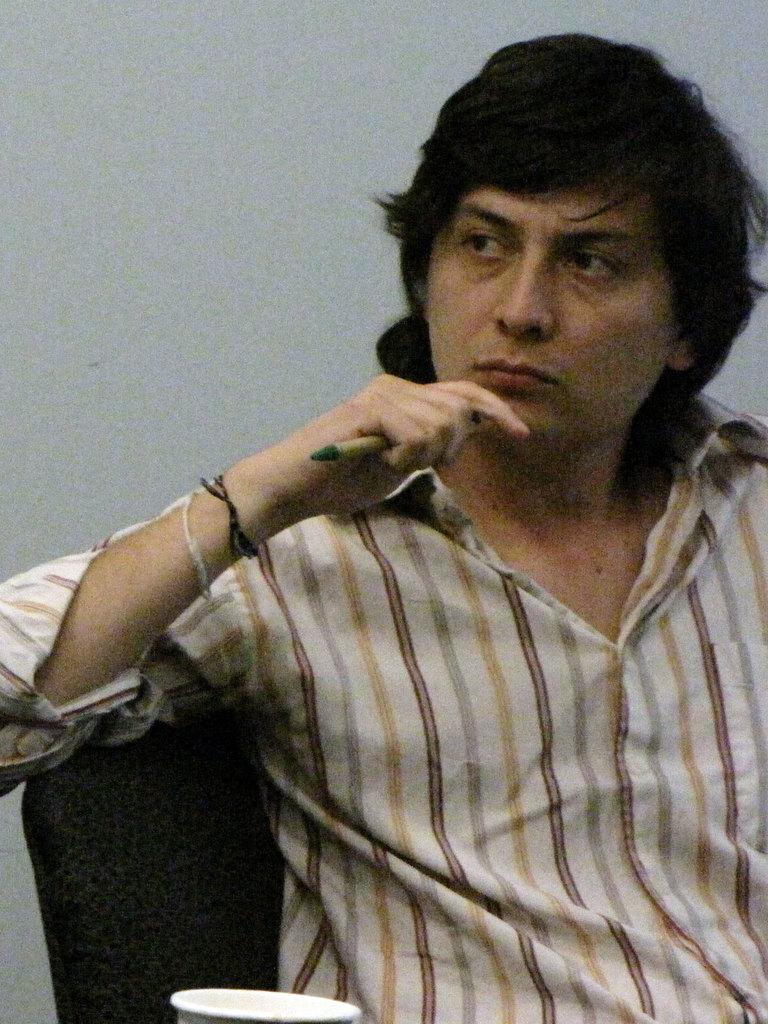What is the person in the image doing? The person is sitting on a chair in the image. What object is the person holding? The person is holding a pen. What can be seen at the bottom of the image? There is a cup at the bottom of the image. What is visible in the background of the image? There is a wall in the background of the image. What type of egg is the person holding in the image? There is no egg present in the image; the person is holding a pen. 